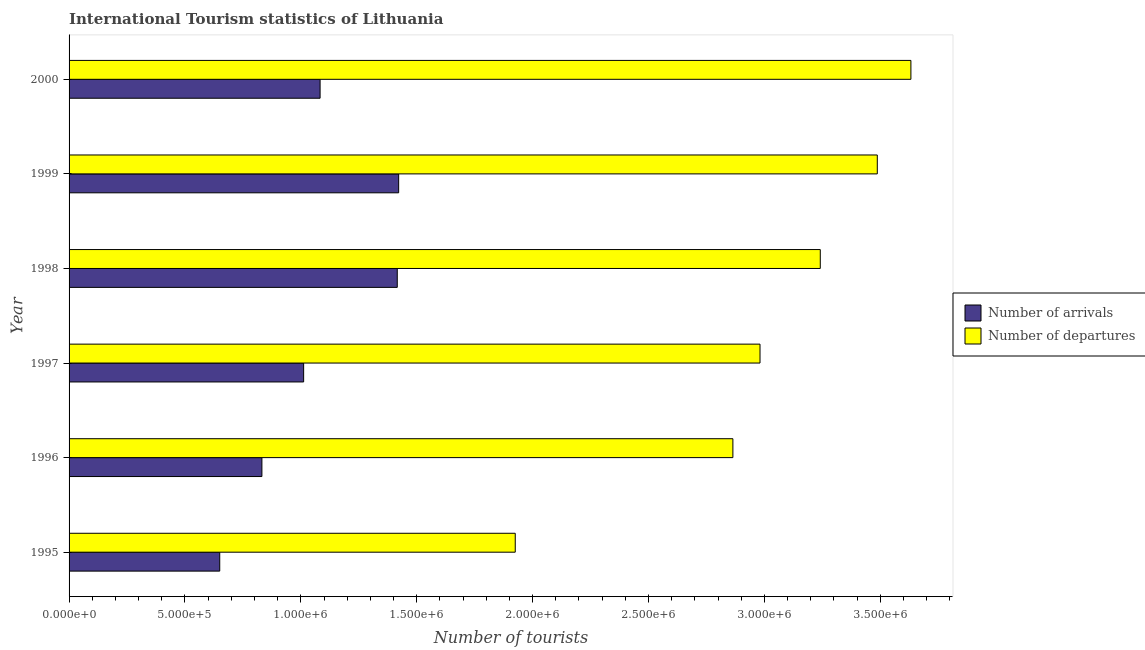How many groups of bars are there?
Make the answer very short. 6. Are the number of bars per tick equal to the number of legend labels?
Your answer should be compact. Yes. Are the number of bars on each tick of the Y-axis equal?
Offer a very short reply. Yes. How many bars are there on the 2nd tick from the top?
Offer a very short reply. 2. In how many cases, is the number of bars for a given year not equal to the number of legend labels?
Give a very brief answer. 0. What is the number of tourist departures in 1995?
Offer a very short reply. 1.92e+06. Across all years, what is the maximum number of tourist departures?
Ensure brevity in your answer.  3.63e+06. Across all years, what is the minimum number of tourist arrivals?
Offer a terse response. 6.50e+05. In which year was the number of tourist departures maximum?
Make the answer very short. 2000. What is the total number of tourist departures in the graph?
Your response must be concise. 1.81e+07. What is the difference between the number of tourist arrivals in 1995 and that in 1996?
Your answer should be compact. -1.82e+05. What is the difference between the number of tourist departures in 1999 and the number of tourist arrivals in 1998?
Offer a terse response. 2.07e+06. What is the average number of tourist departures per year?
Offer a very short reply. 3.02e+06. In the year 2000, what is the difference between the number of tourist arrivals and number of tourist departures?
Your answer should be very brief. -2.55e+06. In how many years, is the number of tourist arrivals greater than 3500000 ?
Keep it short and to the point. 0. What is the ratio of the number of tourist departures in 1995 to that in 1996?
Offer a terse response. 0.67. Is the number of tourist arrivals in 1995 less than that in 1996?
Make the answer very short. Yes. What is the difference between the highest and the second highest number of tourist arrivals?
Offer a very short reply. 6000. What is the difference between the highest and the lowest number of tourist arrivals?
Provide a short and direct response. 7.72e+05. What does the 2nd bar from the top in 1997 represents?
Give a very brief answer. Number of arrivals. What does the 1st bar from the bottom in 1997 represents?
Give a very brief answer. Number of arrivals. How many bars are there?
Give a very brief answer. 12. Does the graph contain any zero values?
Provide a short and direct response. No. Does the graph contain grids?
Keep it short and to the point. No. How are the legend labels stacked?
Make the answer very short. Vertical. What is the title of the graph?
Provide a short and direct response. International Tourism statistics of Lithuania. What is the label or title of the X-axis?
Your response must be concise. Number of tourists. What is the Number of tourists in Number of arrivals in 1995?
Your answer should be very brief. 6.50e+05. What is the Number of tourists of Number of departures in 1995?
Keep it short and to the point. 1.92e+06. What is the Number of tourists in Number of arrivals in 1996?
Provide a succinct answer. 8.32e+05. What is the Number of tourists in Number of departures in 1996?
Your answer should be very brief. 2.86e+06. What is the Number of tourists of Number of arrivals in 1997?
Your response must be concise. 1.01e+06. What is the Number of tourists in Number of departures in 1997?
Provide a short and direct response. 2.98e+06. What is the Number of tourists in Number of arrivals in 1998?
Provide a short and direct response. 1.42e+06. What is the Number of tourists in Number of departures in 1998?
Provide a short and direct response. 3.24e+06. What is the Number of tourists of Number of arrivals in 1999?
Your response must be concise. 1.42e+06. What is the Number of tourists of Number of departures in 1999?
Offer a terse response. 3.49e+06. What is the Number of tourists of Number of arrivals in 2000?
Your answer should be very brief. 1.08e+06. What is the Number of tourists in Number of departures in 2000?
Your answer should be compact. 3.63e+06. Across all years, what is the maximum Number of tourists in Number of arrivals?
Offer a terse response. 1.42e+06. Across all years, what is the maximum Number of tourists of Number of departures?
Your response must be concise. 3.63e+06. Across all years, what is the minimum Number of tourists of Number of arrivals?
Give a very brief answer. 6.50e+05. Across all years, what is the minimum Number of tourists of Number of departures?
Give a very brief answer. 1.92e+06. What is the total Number of tourists of Number of arrivals in the graph?
Make the answer very short. 6.42e+06. What is the total Number of tourists in Number of departures in the graph?
Your response must be concise. 1.81e+07. What is the difference between the Number of tourists in Number of arrivals in 1995 and that in 1996?
Give a very brief answer. -1.82e+05. What is the difference between the Number of tourists of Number of departures in 1995 and that in 1996?
Your answer should be very brief. -9.39e+05. What is the difference between the Number of tourists in Number of arrivals in 1995 and that in 1997?
Offer a very short reply. -3.62e+05. What is the difference between the Number of tourists of Number of departures in 1995 and that in 1997?
Provide a short and direct response. -1.06e+06. What is the difference between the Number of tourists of Number of arrivals in 1995 and that in 1998?
Your answer should be very brief. -7.66e+05. What is the difference between the Number of tourists of Number of departures in 1995 and that in 1998?
Provide a short and direct response. -1.32e+06. What is the difference between the Number of tourists of Number of arrivals in 1995 and that in 1999?
Ensure brevity in your answer.  -7.72e+05. What is the difference between the Number of tourists of Number of departures in 1995 and that in 1999?
Your answer should be very brief. -1.56e+06. What is the difference between the Number of tourists in Number of arrivals in 1995 and that in 2000?
Ensure brevity in your answer.  -4.33e+05. What is the difference between the Number of tourists in Number of departures in 1995 and that in 2000?
Offer a terse response. -1.71e+06. What is the difference between the Number of tourists in Number of departures in 1996 and that in 1997?
Give a very brief answer. -1.17e+05. What is the difference between the Number of tourists in Number of arrivals in 1996 and that in 1998?
Give a very brief answer. -5.84e+05. What is the difference between the Number of tourists of Number of departures in 1996 and that in 1998?
Provide a succinct answer. -3.77e+05. What is the difference between the Number of tourists of Number of arrivals in 1996 and that in 1999?
Keep it short and to the point. -5.90e+05. What is the difference between the Number of tourists in Number of departures in 1996 and that in 1999?
Your answer should be very brief. -6.23e+05. What is the difference between the Number of tourists of Number of arrivals in 1996 and that in 2000?
Provide a succinct answer. -2.51e+05. What is the difference between the Number of tourists of Number of departures in 1996 and that in 2000?
Provide a succinct answer. -7.68e+05. What is the difference between the Number of tourists in Number of arrivals in 1997 and that in 1998?
Keep it short and to the point. -4.04e+05. What is the difference between the Number of tourists of Number of arrivals in 1997 and that in 1999?
Your answer should be compact. -4.10e+05. What is the difference between the Number of tourists of Number of departures in 1997 and that in 1999?
Make the answer very short. -5.06e+05. What is the difference between the Number of tourists in Number of arrivals in 1997 and that in 2000?
Offer a terse response. -7.10e+04. What is the difference between the Number of tourists in Number of departures in 1997 and that in 2000?
Your answer should be very brief. -6.51e+05. What is the difference between the Number of tourists of Number of arrivals in 1998 and that in 1999?
Provide a succinct answer. -6000. What is the difference between the Number of tourists in Number of departures in 1998 and that in 1999?
Provide a short and direct response. -2.46e+05. What is the difference between the Number of tourists of Number of arrivals in 1998 and that in 2000?
Make the answer very short. 3.33e+05. What is the difference between the Number of tourists in Number of departures in 1998 and that in 2000?
Your response must be concise. -3.91e+05. What is the difference between the Number of tourists in Number of arrivals in 1999 and that in 2000?
Your answer should be compact. 3.39e+05. What is the difference between the Number of tourists in Number of departures in 1999 and that in 2000?
Provide a short and direct response. -1.45e+05. What is the difference between the Number of tourists of Number of arrivals in 1995 and the Number of tourists of Number of departures in 1996?
Provide a succinct answer. -2.21e+06. What is the difference between the Number of tourists in Number of arrivals in 1995 and the Number of tourists in Number of departures in 1997?
Give a very brief answer. -2.33e+06. What is the difference between the Number of tourists of Number of arrivals in 1995 and the Number of tourists of Number of departures in 1998?
Keep it short and to the point. -2.59e+06. What is the difference between the Number of tourists in Number of arrivals in 1995 and the Number of tourists in Number of departures in 1999?
Offer a very short reply. -2.84e+06. What is the difference between the Number of tourists in Number of arrivals in 1995 and the Number of tourists in Number of departures in 2000?
Keep it short and to the point. -2.98e+06. What is the difference between the Number of tourists in Number of arrivals in 1996 and the Number of tourists in Number of departures in 1997?
Your answer should be very brief. -2.15e+06. What is the difference between the Number of tourists in Number of arrivals in 1996 and the Number of tourists in Number of departures in 1998?
Your answer should be compact. -2.41e+06. What is the difference between the Number of tourists of Number of arrivals in 1996 and the Number of tourists of Number of departures in 1999?
Your response must be concise. -2.66e+06. What is the difference between the Number of tourists in Number of arrivals in 1996 and the Number of tourists in Number of departures in 2000?
Your response must be concise. -2.80e+06. What is the difference between the Number of tourists of Number of arrivals in 1997 and the Number of tourists of Number of departures in 1998?
Give a very brief answer. -2.23e+06. What is the difference between the Number of tourists of Number of arrivals in 1997 and the Number of tourists of Number of departures in 1999?
Provide a short and direct response. -2.48e+06. What is the difference between the Number of tourists in Number of arrivals in 1997 and the Number of tourists in Number of departures in 2000?
Your answer should be very brief. -2.62e+06. What is the difference between the Number of tourists of Number of arrivals in 1998 and the Number of tourists of Number of departures in 1999?
Keep it short and to the point. -2.07e+06. What is the difference between the Number of tourists in Number of arrivals in 1998 and the Number of tourists in Number of departures in 2000?
Provide a succinct answer. -2.22e+06. What is the difference between the Number of tourists of Number of arrivals in 1999 and the Number of tourists of Number of departures in 2000?
Make the answer very short. -2.21e+06. What is the average Number of tourists in Number of arrivals per year?
Give a very brief answer. 1.07e+06. What is the average Number of tourists of Number of departures per year?
Make the answer very short. 3.02e+06. In the year 1995, what is the difference between the Number of tourists in Number of arrivals and Number of tourists in Number of departures?
Your answer should be very brief. -1.28e+06. In the year 1996, what is the difference between the Number of tourists in Number of arrivals and Number of tourists in Number of departures?
Ensure brevity in your answer.  -2.03e+06. In the year 1997, what is the difference between the Number of tourists in Number of arrivals and Number of tourists in Number of departures?
Provide a short and direct response. -1.97e+06. In the year 1998, what is the difference between the Number of tourists of Number of arrivals and Number of tourists of Number of departures?
Keep it short and to the point. -1.82e+06. In the year 1999, what is the difference between the Number of tourists in Number of arrivals and Number of tourists in Number of departures?
Offer a terse response. -2.06e+06. In the year 2000, what is the difference between the Number of tourists in Number of arrivals and Number of tourists in Number of departures?
Offer a terse response. -2.55e+06. What is the ratio of the Number of tourists in Number of arrivals in 1995 to that in 1996?
Give a very brief answer. 0.78. What is the ratio of the Number of tourists of Number of departures in 1995 to that in 1996?
Make the answer very short. 0.67. What is the ratio of the Number of tourists in Number of arrivals in 1995 to that in 1997?
Ensure brevity in your answer.  0.64. What is the ratio of the Number of tourists in Number of departures in 1995 to that in 1997?
Keep it short and to the point. 0.65. What is the ratio of the Number of tourists in Number of arrivals in 1995 to that in 1998?
Keep it short and to the point. 0.46. What is the ratio of the Number of tourists in Number of departures in 1995 to that in 1998?
Give a very brief answer. 0.59. What is the ratio of the Number of tourists of Number of arrivals in 1995 to that in 1999?
Offer a terse response. 0.46. What is the ratio of the Number of tourists of Number of departures in 1995 to that in 1999?
Keep it short and to the point. 0.55. What is the ratio of the Number of tourists in Number of arrivals in 1995 to that in 2000?
Offer a terse response. 0.6. What is the ratio of the Number of tourists in Number of departures in 1995 to that in 2000?
Offer a terse response. 0.53. What is the ratio of the Number of tourists in Number of arrivals in 1996 to that in 1997?
Offer a very short reply. 0.82. What is the ratio of the Number of tourists in Number of departures in 1996 to that in 1997?
Keep it short and to the point. 0.96. What is the ratio of the Number of tourists of Number of arrivals in 1996 to that in 1998?
Your answer should be very brief. 0.59. What is the ratio of the Number of tourists in Number of departures in 1996 to that in 1998?
Offer a very short reply. 0.88. What is the ratio of the Number of tourists in Number of arrivals in 1996 to that in 1999?
Offer a terse response. 0.59. What is the ratio of the Number of tourists of Number of departures in 1996 to that in 1999?
Keep it short and to the point. 0.82. What is the ratio of the Number of tourists in Number of arrivals in 1996 to that in 2000?
Give a very brief answer. 0.77. What is the ratio of the Number of tourists of Number of departures in 1996 to that in 2000?
Your answer should be very brief. 0.79. What is the ratio of the Number of tourists in Number of arrivals in 1997 to that in 1998?
Keep it short and to the point. 0.71. What is the ratio of the Number of tourists of Number of departures in 1997 to that in 1998?
Provide a short and direct response. 0.92. What is the ratio of the Number of tourists in Number of arrivals in 1997 to that in 1999?
Your answer should be very brief. 0.71. What is the ratio of the Number of tourists in Number of departures in 1997 to that in 1999?
Provide a short and direct response. 0.85. What is the ratio of the Number of tourists of Number of arrivals in 1997 to that in 2000?
Provide a succinct answer. 0.93. What is the ratio of the Number of tourists of Number of departures in 1997 to that in 2000?
Keep it short and to the point. 0.82. What is the ratio of the Number of tourists of Number of departures in 1998 to that in 1999?
Keep it short and to the point. 0.93. What is the ratio of the Number of tourists in Number of arrivals in 1998 to that in 2000?
Provide a short and direct response. 1.31. What is the ratio of the Number of tourists of Number of departures in 1998 to that in 2000?
Your response must be concise. 0.89. What is the ratio of the Number of tourists in Number of arrivals in 1999 to that in 2000?
Your answer should be compact. 1.31. What is the ratio of the Number of tourists in Number of departures in 1999 to that in 2000?
Your response must be concise. 0.96. What is the difference between the highest and the second highest Number of tourists of Number of arrivals?
Your answer should be very brief. 6000. What is the difference between the highest and the second highest Number of tourists in Number of departures?
Your response must be concise. 1.45e+05. What is the difference between the highest and the lowest Number of tourists in Number of arrivals?
Offer a very short reply. 7.72e+05. What is the difference between the highest and the lowest Number of tourists of Number of departures?
Make the answer very short. 1.71e+06. 